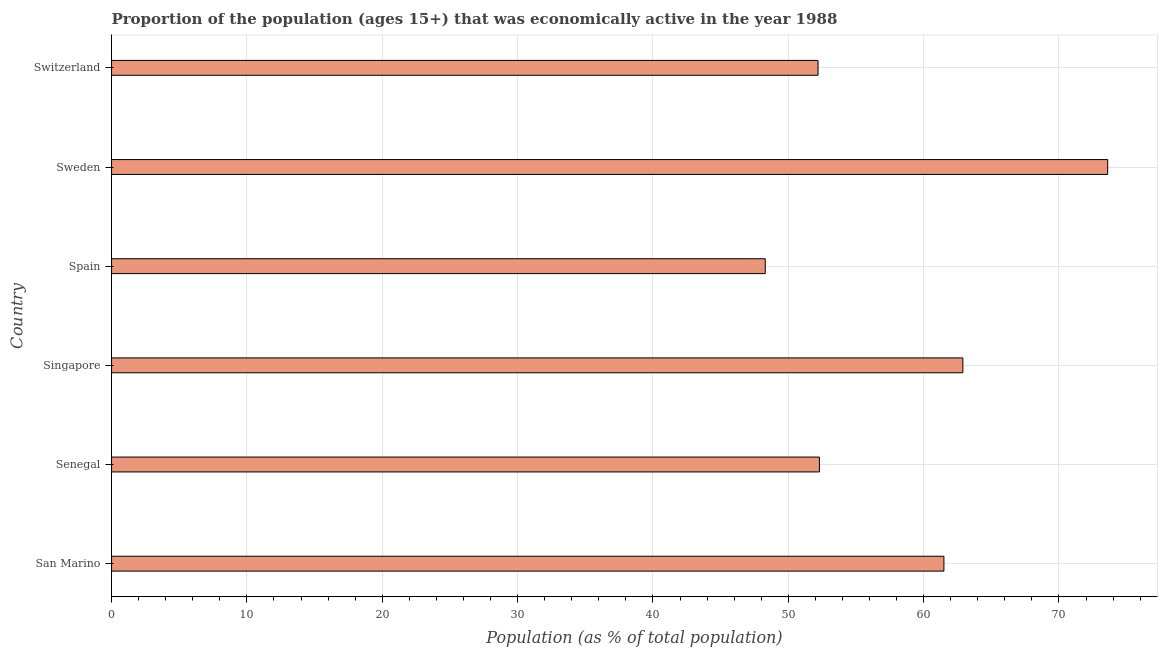Does the graph contain any zero values?
Give a very brief answer. No. Does the graph contain grids?
Offer a very short reply. Yes. What is the title of the graph?
Your answer should be very brief. Proportion of the population (ages 15+) that was economically active in the year 1988. What is the label or title of the X-axis?
Offer a very short reply. Population (as % of total population). What is the label or title of the Y-axis?
Your answer should be compact. Country. What is the percentage of economically active population in Singapore?
Your answer should be compact. 62.9. Across all countries, what is the maximum percentage of economically active population?
Your answer should be compact. 73.6. Across all countries, what is the minimum percentage of economically active population?
Make the answer very short. 48.3. In which country was the percentage of economically active population minimum?
Provide a short and direct response. Spain. What is the sum of the percentage of economically active population?
Make the answer very short. 350.8. What is the average percentage of economically active population per country?
Offer a very short reply. 58.47. What is the median percentage of economically active population?
Your answer should be very brief. 56.9. What is the ratio of the percentage of economically active population in Senegal to that in Singapore?
Your answer should be compact. 0.83. Is the percentage of economically active population in San Marino less than that in Spain?
Your answer should be very brief. No. What is the difference between the highest and the lowest percentage of economically active population?
Make the answer very short. 25.3. Are all the bars in the graph horizontal?
Ensure brevity in your answer.  Yes. What is the Population (as % of total population) of San Marino?
Keep it short and to the point. 61.5. What is the Population (as % of total population) of Senegal?
Keep it short and to the point. 52.3. What is the Population (as % of total population) in Singapore?
Provide a succinct answer. 62.9. What is the Population (as % of total population) of Spain?
Your answer should be compact. 48.3. What is the Population (as % of total population) of Sweden?
Keep it short and to the point. 73.6. What is the Population (as % of total population) in Switzerland?
Make the answer very short. 52.2. What is the difference between the Population (as % of total population) in Senegal and Singapore?
Ensure brevity in your answer.  -10.6. What is the difference between the Population (as % of total population) in Senegal and Sweden?
Provide a short and direct response. -21.3. What is the difference between the Population (as % of total population) in Singapore and Spain?
Keep it short and to the point. 14.6. What is the difference between the Population (as % of total population) in Spain and Sweden?
Provide a succinct answer. -25.3. What is the difference between the Population (as % of total population) in Sweden and Switzerland?
Your answer should be very brief. 21.4. What is the ratio of the Population (as % of total population) in San Marino to that in Senegal?
Give a very brief answer. 1.18. What is the ratio of the Population (as % of total population) in San Marino to that in Singapore?
Offer a terse response. 0.98. What is the ratio of the Population (as % of total population) in San Marino to that in Spain?
Your answer should be very brief. 1.27. What is the ratio of the Population (as % of total population) in San Marino to that in Sweden?
Provide a short and direct response. 0.84. What is the ratio of the Population (as % of total population) in San Marino to that in Switzerland?
Your answer should be very brief. 1.18. What is the ratio of the Population (as % of total population) in Senegal to that in Singapore?
Offer a very short reply. 0.83. What is the ratio of the Population (as % of total population) in Senegal to that in Spain?
Give a very brief answer. 1.08. What is the ratio of the Population (as % of total population) in Senegal to that in Sweden?
Your answer should be compact. 0.71. What is the ratio of the Population (as % of total population) in Senegal to that in Switzerland?
Keep it short and to the point. 1. What is the ratio of the Population (as % of total population) in Singapore to that in Spain?
Your answer should be very brief. 1.3. What is the ratio of the Population (as % of total population) in Singapore to that in Sweden?
Offer a terse response. 0.85. What is the ratio of the Population (as % of total population) in Singapore to that in Switzerland?
Your answer should be very brief. 1.21. What is the ratio of the Population (as % of total population) in Spain to that in Sweden?
Keep it short and to the point. 0.66. What is the ratio of the Population (as % of total population) in Spain to that in Switzerland?
Provide a succinct answer. 0.93. What is the ratio of the Population (as % of total population) in Sweden to that in Switzerland?
Your response must be concise. 1.41. 